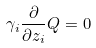Convert formula to latex. <formula><loc_0><loc_0><loc_500><loc_500>\gamma _ { i } \frac { \partial } { \partial z _ { i } } Q = 0</formula> 